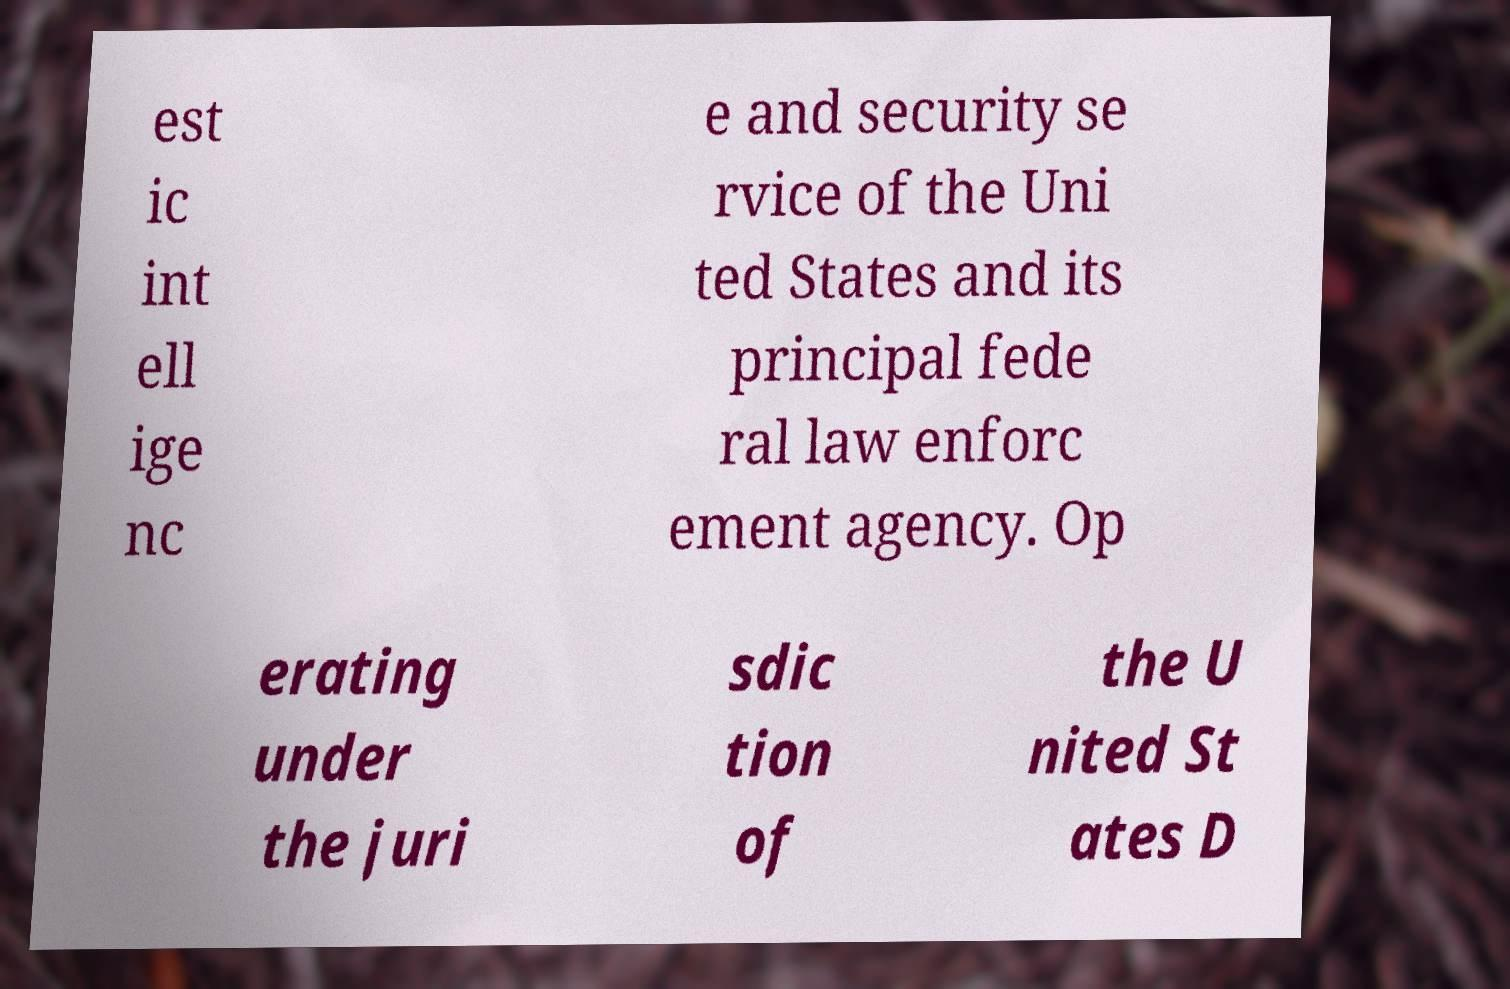There's text embedded in this image that I need extracted. Can you transcribe it verbatim? est ic int ell ige nc e and security se rvice of the Uni ted States and its principal fede ral law enforc ement agency. Op erating under the juri sdic tion of the U nited St ates D 